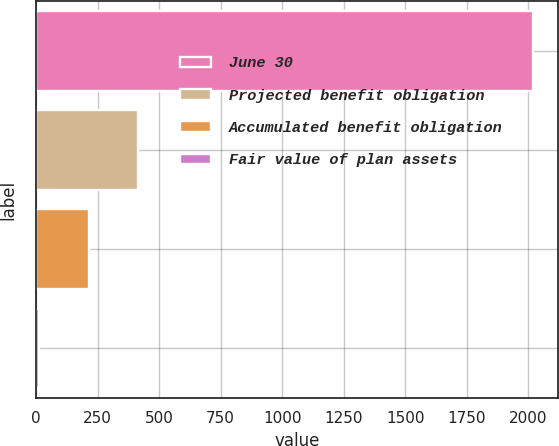<chart> <loc_0><loc_0><loc_500><loc_500><bar_chart><fcel>June 30<fcel>Projected benefit obligation<fcel>Accumulated benefit obligation<fcel>Fair value of plan assets<nl><fcel>2018<fcel>414.24<fcel>213.77<fcel>13.3<nl></chart> 